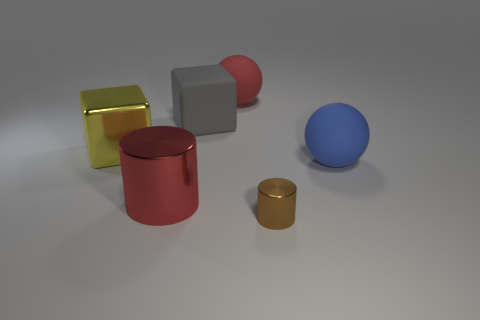What number of other things are the same color as the big shiny cylinder?
Offer a very short reply. 1. What number of big matte spheres are on the right side of the shiny thing that is to the right of the gray matte object that is to the left of the brown metal thing?
Your response must be concise. 1. There is a block on the right side of the big yellow thing; what is its size?
Provide a short and direct response. Large. Is the shape of the large thing to the right of the small brown shiny object the same as  the brown metal object?
Your answer should be compact. No. There is a yellow object that is the same shape as the gray matte thing; what is its material?
Your response must be concise. Metal. Is there any other thing that has the same size as the gray matte object?
Make the answer very short. Yes. Are there any red objects?
Make the answer very short. Yes. There is a big red object that is in front of the rubber sphere that is right of the large sphere that is behind the big yellow metallic object; what is it made of?
Your answer should be compact. Metal. Does the brown thing have the same shape as the big rubber thing that is in front of the large yellow thing?
Keep it short and to the point. No. How many big blue rubber things are the same shape as the tiny brown metal object?
Your response must be concise. 0. 